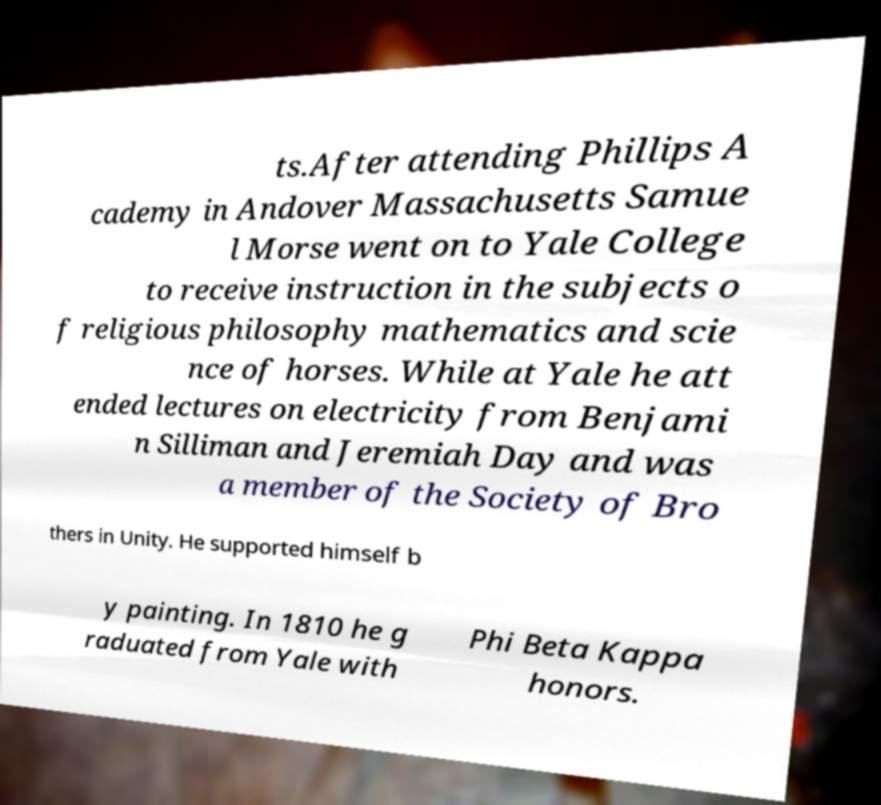Please read and relay the text visible in this image. What does it say? ts.After attending Phillips A cademy in Andover Massachusetts Samue l Morse went on to Yale College to receive instruction in the subjects o f religious philosophy mathematics and scie nce of horses. While at Yale he att ended lectures on electricity from Benjami n Silliman and Jeremiah Day and was a member of the Society of Bro thers in Unity. He supported himself b y painting. In 1810 he g raduated from Yale with Phi Beta Kappa honors. 